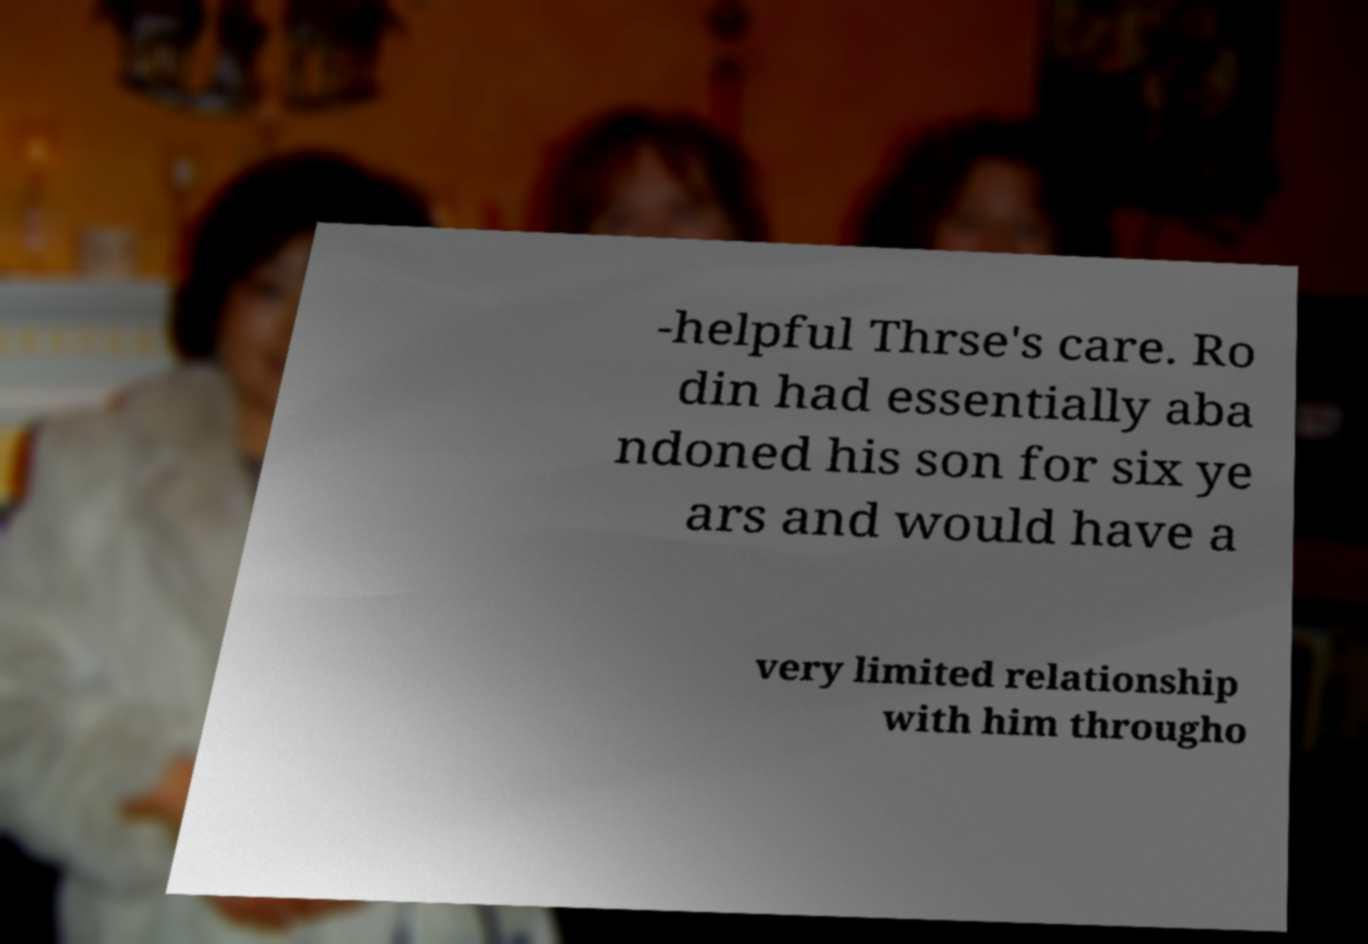Can you read and provide the text displayed in the image?This photo seems to have some interesting text. Can you extract and type it out for me? -helpful Thrse's care. Ro din had essentially aba ndoned his son for six ye ars and would have a very limited relationship with him througho 